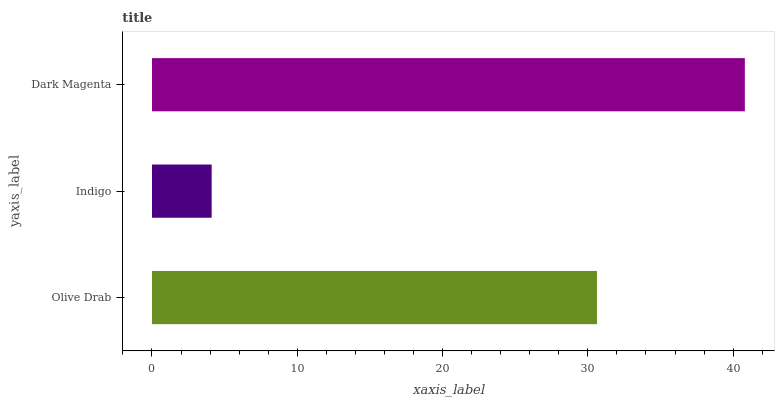Is Indigo the minimum?
Answer yes or no. Yes. Is Dark Magenta the maximum?
Answer yes or no. Yes. Is Dark Magenta the minimum?
Answer yes or no. No. Is Indigo the maximum?
Answer yes or no. No. Is Dark Magenta greater than Indigo?
Answer yes or no. Yes. Is Indigo less than Dark Magenta?
Answer yes or no. Yes. Is Indigo greater than Dark Magenta?
Answer yes or no. No. Is Dark Magenta less than Indigo?
Answer yes or no. No. Is Olive Drab the high median?
Answer yes or no. Yes. Is Olive Drab the low median?
Answer yes or no. Yes. Is Indigo the high median?
Answer yes or no. No. Is Indigo the low median?
Answer yes or no. No. 